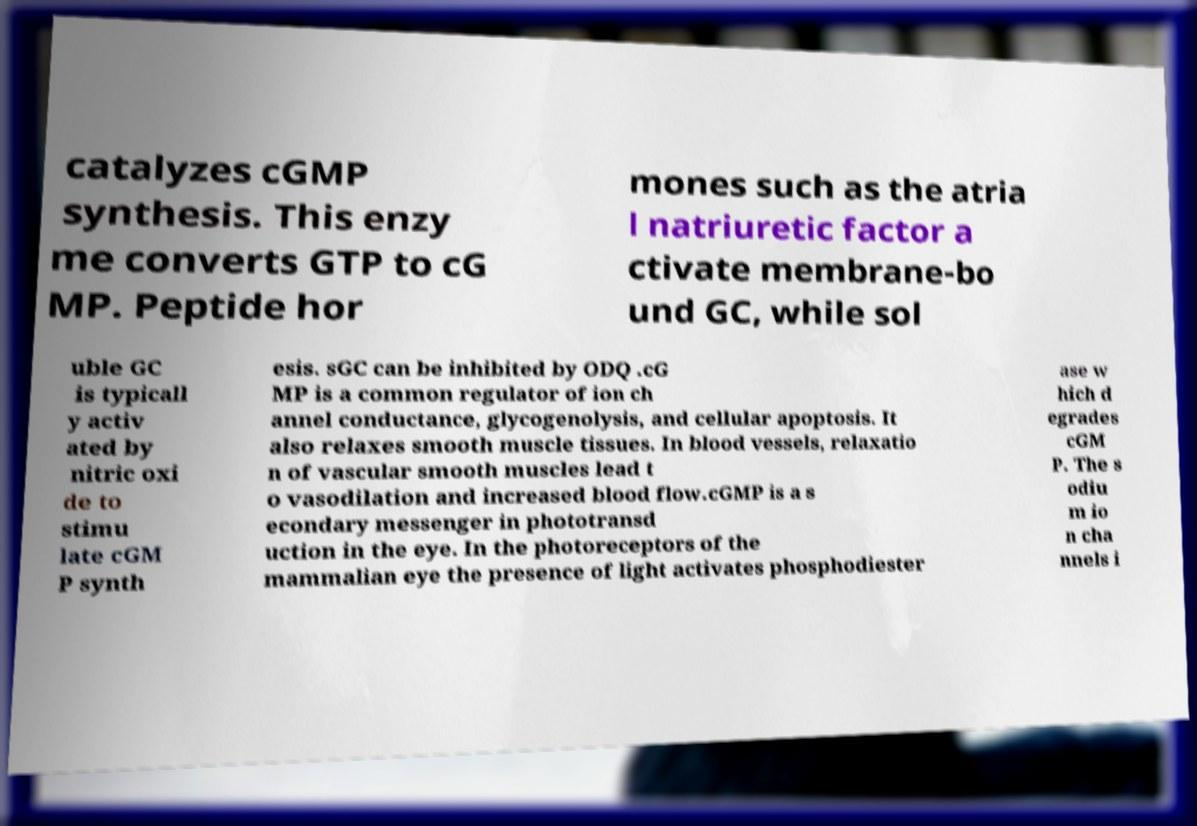I need the written content from this picture converted into text. Can you do that? catalyzes cGMP synthesis. This enzy me converts GTP to cG MP. Peptide hor mones such as the atria l natriuretic factor a ctivate membrane-bo und GC, while sol uble GC is typicall y activ ated by nitric oxi de to stimu late cGM P synth esis. sGC can be inhibited by ODQ .cG MP is a common regulator of ion ch annel conductance, glycogenolysis, and cellular apoptosis. It also relaxes smooth muscle tissues. In blood vessels, relaxatio n of vascular smooth muscles lead t o vasodilation and increased blood flow.cGMP is a s econdary messenger in phototransd uction in the eye. In the photoreceptors of the mammalian eye the presence of light activates phosphodiester ase w hich d egrades cGM P. The s odiu m io n cha nnels i 